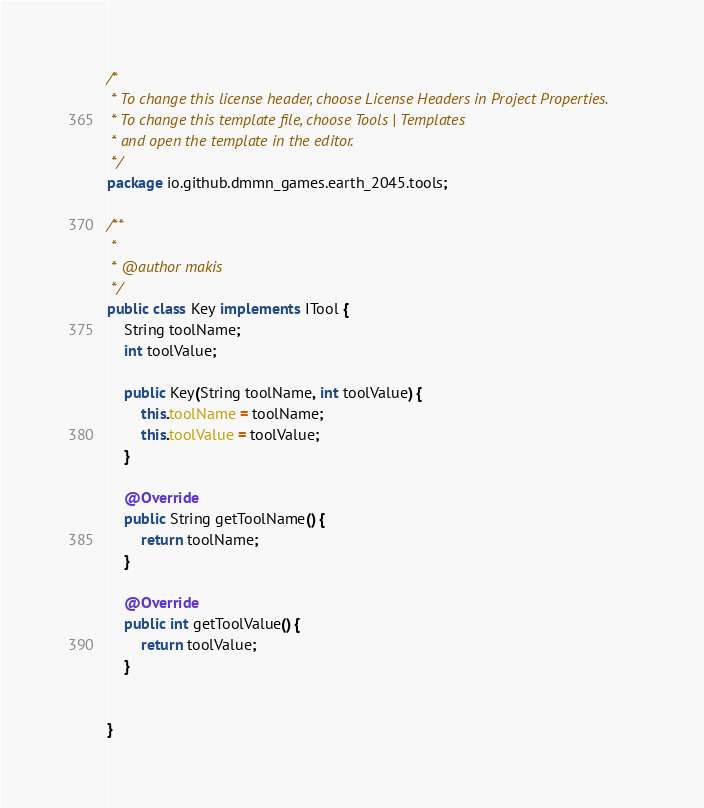Convert code to text. <code><loc_0><loc_0><loc_500><loc_500><_Java_>/*
 * To change this license header, choose License Headers in Project Properties.
 * To change this template file, choose Tools | Templates
 * and open the template in the editor.
 */
package io.github.dmmn_games.earth_2045.tools;

/**
 *
 * @author makis
 */
public class Key implements ITool {
    String toolName;
    int toolValue;

    public Key(String toolName, int toolValue) {
        this.toolName = toolName;
        this.toolValue = toolValue;
    }
    
    @Override
    public String getToolName() {
        return toolName;
    }
    
    @Override
    public int getToolValue() {
        return toolValue;
    }

    
}
</code> 